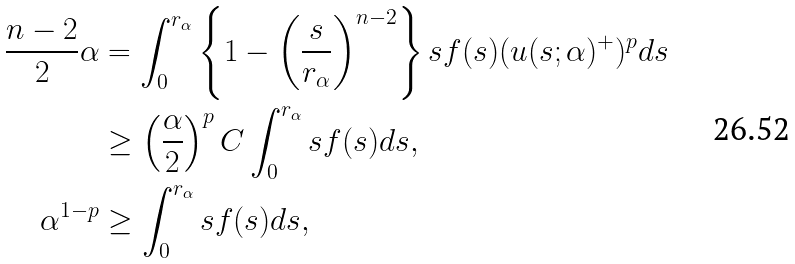<formula> <loc_0><loc_0><loc_500><loc_500>\frac { n - 2 } { 2 } \alpha & = \int _ { 0 } ^ { r _ { \alpha } } \left \{ 1 - \left ( \frac { s } { r _ { \alpha } } \right ) ^ { n - 2 } \right \} s f ( s ) ( u ( s ; \alpha ) ^ { + } ) ^ { p } d s \\ & \geq \left ( \frac { \alpha } { 2 } \right ) ^ { p } C \int _ { 0 } ^ { r _ { \alpha } } s f ( s ) d s , \\ \alpha ^ { 1 - p } & \geq \int _ { 0 } ^ { r _ { \alpha } } s f ( s ) d s ,</formula> 